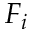<formula> <loc_0><loc_0><loc_500><loc_500>F _ { i }</formula> 